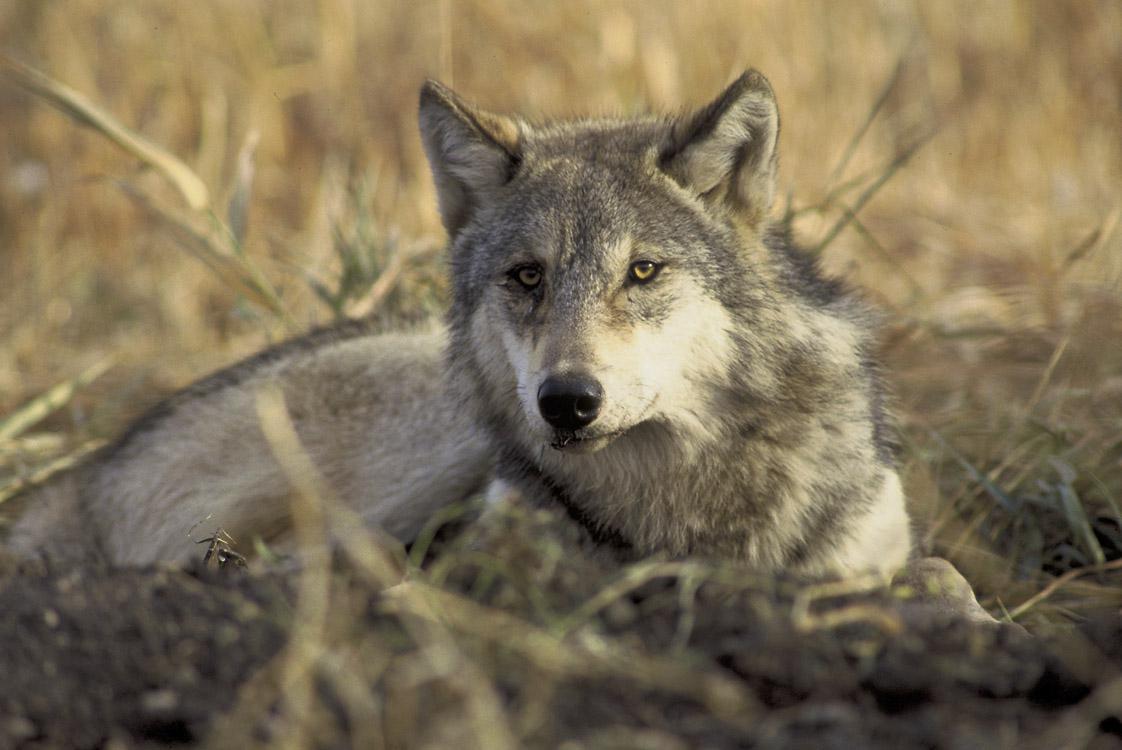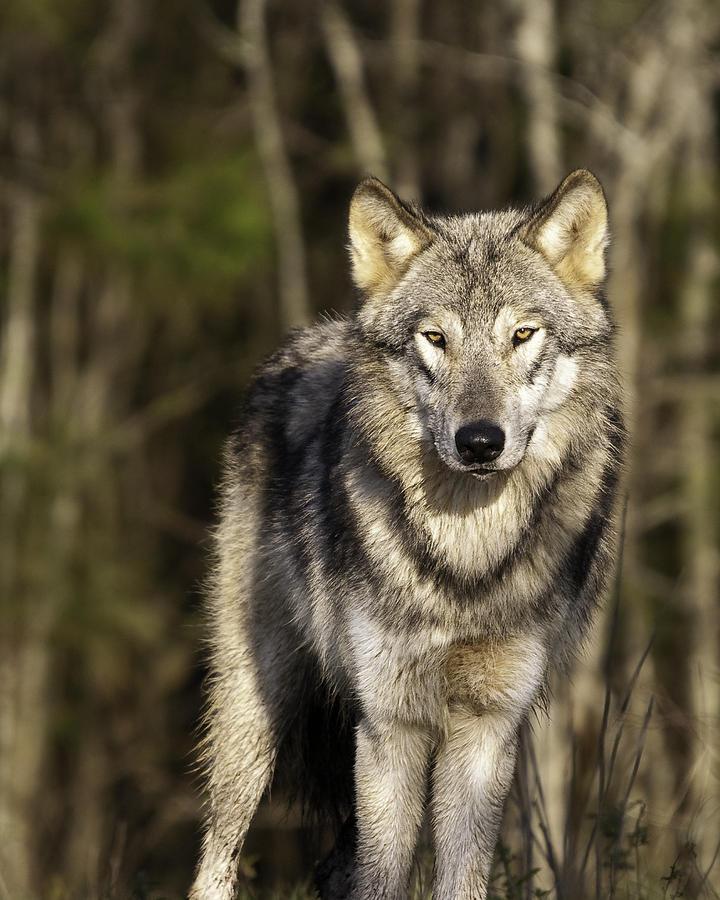The first image is the image on the left, the second image is the image on the right. Analyze the images presented: Is the assertion "An image shows a standing wolf facing the camera." valid? Answer yes or no. Yes. The first image is the image on the left, the second image is the image on the right. Given the left and right images, does the statement "The animal in the image on the right is looking toward the camera" hold true? Answer yes or no. Yes. 